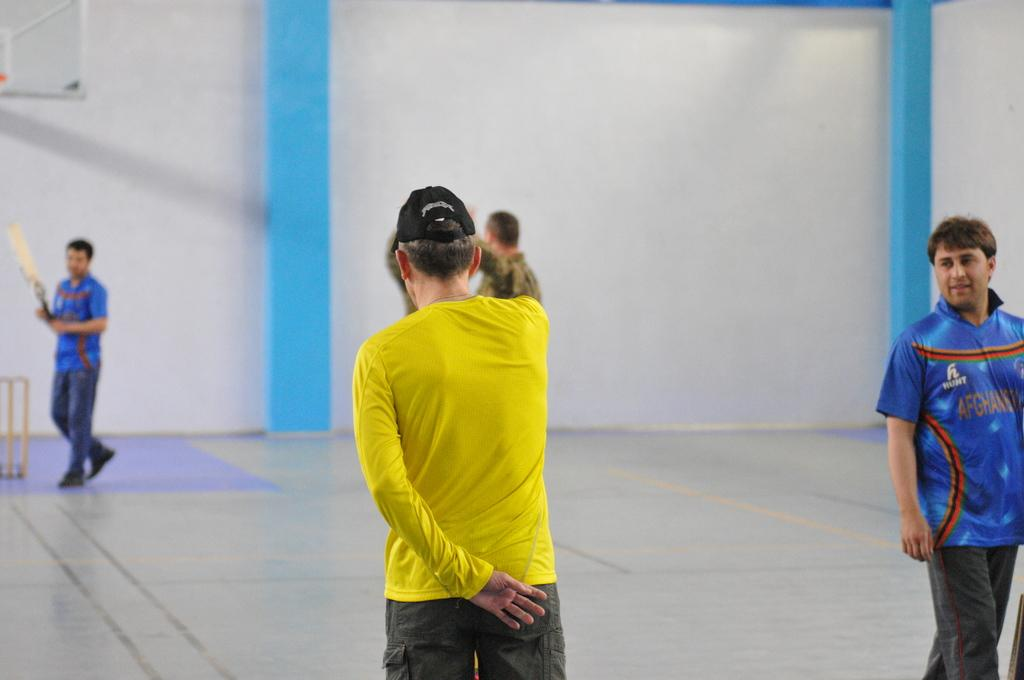Provide a one-sentence caption for the provided image. a person in a yellow shirt next to a man in a blue Afghanistan shirt. 